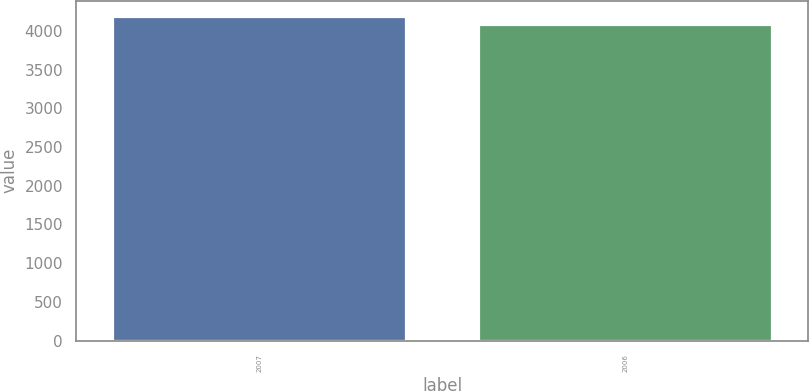Convert chart to OTSL. <chart><loc_0><loc_0><loc_500><loc_500><bar_chart><fcel>2007<fcel>2006<nl><fcel>4177.7<fcel>4079.6<nl></chart> 